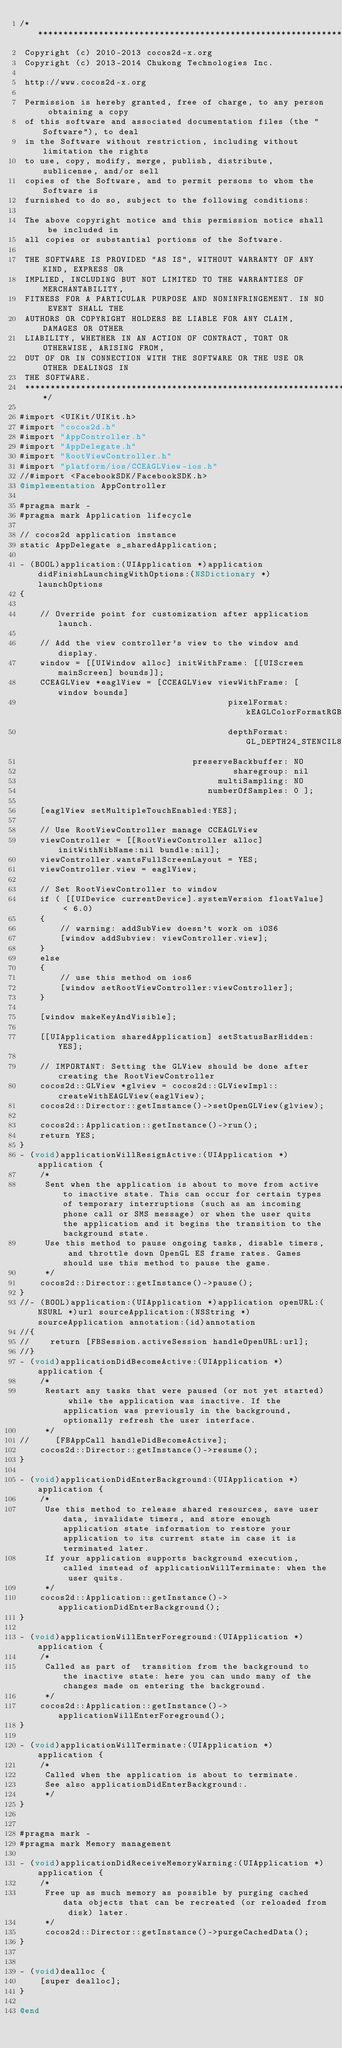Convert code to text. <code><loc_0><loc_0><loc_500><loc_500><_ObjectiveC_>/****************************************************************************
 Copyright (c) 2010-2013 cocos2d-x.org
 Copyright (c) 2013-2014 Chukong Technologies Inc.

 http://www.cocos2d-x.org

 Permission is hereby granted, free of charge, to any person obtaining a copy
 of this software and associated documentation files (the "Software"), to deal
 in the Software without restriction, including without limitation the rights
 to use, copy, modify, merge, publish, distribute, sublicense, and/or sell
 copies of the Software, and to permit persons to whom the Software is
 furnished to do so, subject to the following conditions:

 The above copyright notice and this permission notice shall be included in
 all copies or substantial portions of the Software.

 THE SOFTWARE IS PROVIDED "AS IS", WITHOUT WARRANTY OF ANY KIND, EXPRESS OR
 IMPLIED, INCLUDING BUT NOT LIMITED TO THE WARRANTIES OF MERCHANTABILITY,
 FITNESS FOR A PARTICULAR PURPOSE AND NONINFRINGEMENT. IN NO EVENT SHALL THE
 AUTHORS OR COPYRIGHT HOLDERS BE LIABLE FOR ANY CLAIM, DAMAGES OR OTHER
 LIABILITY, WHETHER IN AN ACTION OF CONTRACT, TORT OR OTHERWISE, ARISING FROM,
 OUT OF OR IN CONNECTION WITH THE SOFTWARE OR THE USE OR OTHER DEALINGS IN
 THE SOFTWARE.
 ****************************************************************************/

#import <UIKit/UIKit.h>
#import "cocos2d.h"
#import "AppController.h"
#import "AppDelegate.h"
#import "RootViewController.h"
#import "platform/ios/CCEAGLView-ios.h"
//#import <FacebookSDK/FacebookSDK.h>
@implementation AppController

#pragma mark -
#pragma mark Application lifecycle

// cocos2d application instance
static AppDelegate s_sharedApplication;

- (BOOL)application:(UIApplication *)application didFinishLaunchingWithOptions:(NSDictionary *)launchOptions
{

    // Override point for customization after application launch.

    // Add the view controller's view to the window and display.
    window = [[UIWindow alloc] initWithFrame: [[UIScreen mainScreen] bounds]];
    CCEAGLView *eaglView = [CCEAGLView viewWithFrame: [window bounds]
                                         pixelFormat: kEAGLColorFormatRGBA8
                                         depthFormat: GL_DEPTH24_STENCIL8_OES
                                  preserveBackbuffer: NO
                                          sharegroup: nil
                                       multiSampling: NO
                                     numberOfSamples: 0 ];

    [eaglView setMultipleTouchEnabled:YES];
    
    // Use RootViewController manage CCEAGLView
    viewController = [[RootViewController alloc] initWithNibName:nil bundle:nil];
    viewController.wantsFullScreenLayout = YES;
    viewController.view = eaglView;

    // Set RootViewController to window
    if ( [[UIDevice currentDevice].systemVersion floatValue] < 6.0)
    {
        // warning: addSubView doesn't work on iOS6
        [window addSubview: viewController.view];
    }
    else
    {
        // use this method on ios6
        [window setRootViewController:viewController];
    }
    
    [window makeKeyAndVisible];

    [[UIApplication sharedApplication] setStatusBarHidden: YES];

    // IMPORTANT: Setting the GLView should be done after creating the RootViewController
    cocos2d::GLView *glview = cocos2d::GLViewImpl::createWithEAGLView(eaglView);
    cocos2d::Director::getInstance()->setOpenGLView(glview);

    cocos2d::Application::getInstance()->run();
    return YES;
}
- (void)applicationWillResignActive:(UIApplication *)application {
    /*
     Sent when the application is about to move from active to inactive state. This can occur for certain types of temporary interruptions (such as an incoming phone call or SMS message) or when the user quits the application and it begins the transition to the background state.
     Use this method to pause ongoing tasks, disable timers, and throttle down OpenGL ES frame rates. Games should use this method to pause the game.
     */
    cocos2d::Director::getInstance()->pause();
}
//- (BOOL)application:(UIApplication *)application openURL:(NSURL *)url sourceApplication:(NSString *)sourceApplication annotation:(id)annotation
//{
//    return [FBSession.activeSession handleOpenURL:url];
//}
- (void)applicationDidBecomeActive:(UIApplication *)application {
    /*
     Restart any tasks that were paused (or not yet started) while the application was inactive. If the application was previously in the background, optionally refresh the user interface.
     */
//     [FBAppCall handleDidBecomeActive];
    cocos2d::Director::getInstance()->resume();
}

- (void)applicationDidEnterBackground:(UIApplication *)application {
    /*
     Use this method to release shared resources, save user data, invalidate timers, and store enough application state information to restore your application to its current state in case it is terminated later.
     If your application supports background execution, called instead of applicationWillTerminate: when the user quits.
     */
    cocos2d::Application::getInstance()->applicationDidEnterBackground();
}

- (void)applicationWillEnterForeground:(UIApplication *)application {
    /*
     Called as part of  transition from the background to the inactive state: here you can undo many of the changes made on entering the background.
     */
    cocos2d::Application::getInstance()->applicationWillEnterForeground();
}

- (void)applicationWillTerminate:(UIApplication *)application {
    /*
     Called when the application is about to terminate.
     See also applicationDidEnterBackground:.
     */
}


#pragma mark -
#pragma mark Memory management

- (void)applicationDidReceiveMemoryWarning:(UIApplication *)application {
    /*
     Free up as much memory as possible by purging cached data objects that can be recreated (or reloaded from disk) later.
     */
     cocos2d::Director::getInstance()->purgeCachedData();
}


- (void)dealloc {
    [super dealloc];
}

@end

</code> 